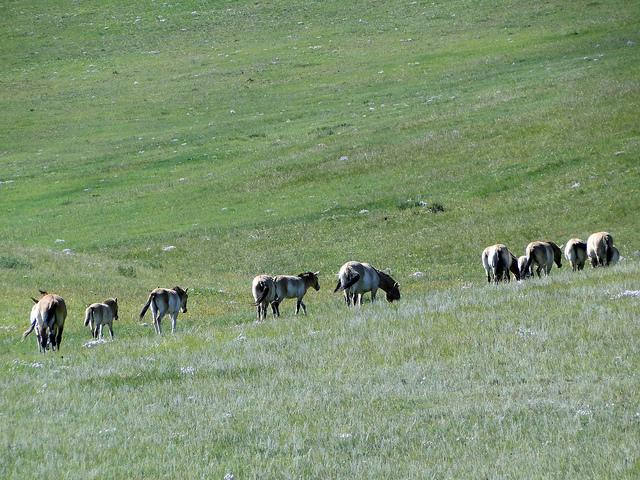What is on the grass? horses 